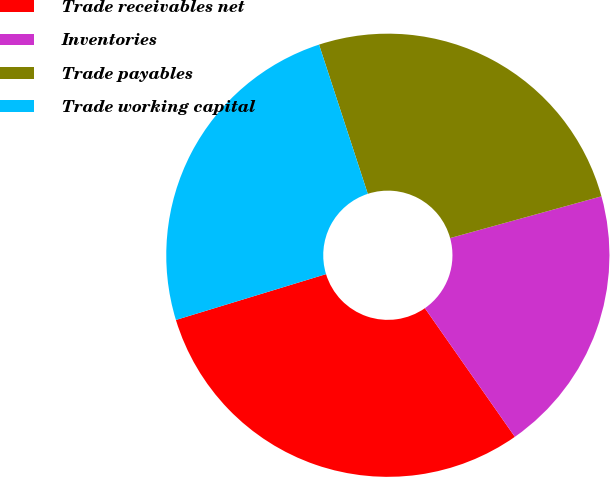<chart> <loc_0><loc_0><loc_500><loc_500><pie_chart><fcel>Trade receivables net<fcel>Inventories<fcel>Trade payables<fcel>Trade working capital<nl><fcel>30.0%<fcel>19.57%<fcel>25.74%<fcel>24.69%<nl></chart> 